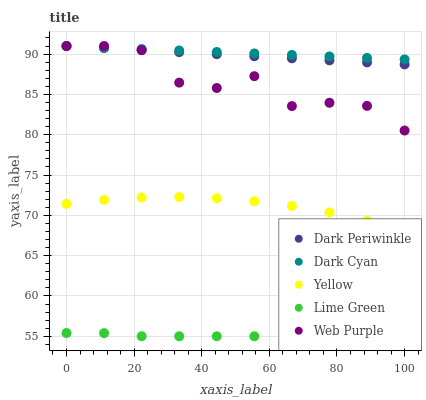Does Lime Green have the minimum area under the curve?
Answer yes or no. Yes. Does Dark Cyan have the maximum area under the curve?
Answer yes or no. Yes. Does Web Purple have the minimum area under the curve?
Answer yes or no. No. Does Web Purple have the maximum area under the curve?
Answer yes or no. No. Is Dark Cyan the smoothest?
Answer yes or no. Yes. Is Web Purple the roughest?
Answer yes or no. Yes. Is Lime Green the smoothest?
Answer yes or no. No. Is Lime Green the roughest?
Answer yes or no. No. Does Lime Green have the lowest value?
Answer yes or no. Yes. Does Web Purple have the lowest value?
Answer yes or no. No. Does Dark Periwinkle have the highest value?
Answer yes or no. Yes. Does Lime Green have the highest value?
Answer yes or no. No. Is Lime Green less than Dark Cyan?
Answer yes or no. Yes. Is Web Purple greater than Yellow?
Answer yes or no. Yes. Does Dark Cyan intersect Web Purple?
Answer yes or no. Yes. Is Dark Cyan less than Web Purple?
Answer yes or no. No. Is Dark Cyan greater than Web Purple?
Answer yes or no. No. Does Lime Green intersect Dark Cyan?
Answer yes or no. No. 